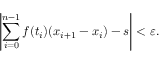Convert formula to latex. <formula><loc_0><loc_0><loc_500><loc_500>\left | \sum _ { i = 0 } ^ { n - 1 } f ( t _ { i } ) ( x _ { i + 1 } - x _ { i } ) - s \right | < \varepsilon .</formula> 